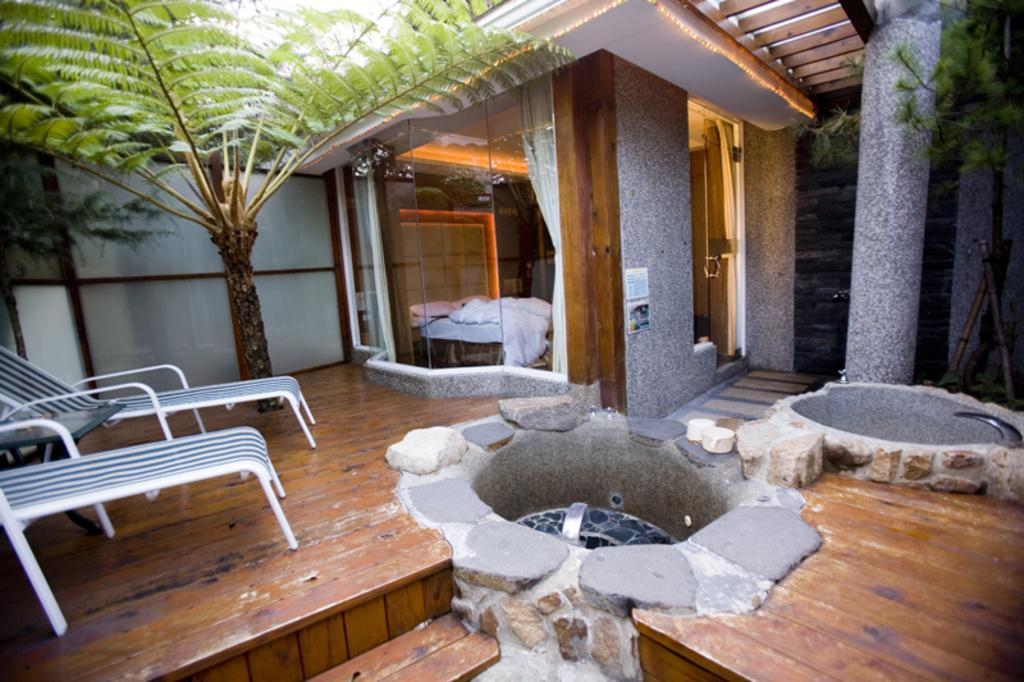What type of furniture can be seen in the image? There are chairs and a table in the image. What is located in the center of the image? There is a bed in the center of the image. What type of vegetation is visible on both sides of the image? Trees are visible on both sides of the image. What type of window treatment is present in the image? There are curtains in the image. What architectural feature is present in the image? There is a door in the image. Who is the actor that appears in the image? There is no actor present in the image. Who is the creator of the bed in the image? The creator of the bed is not mentioned in the image. 